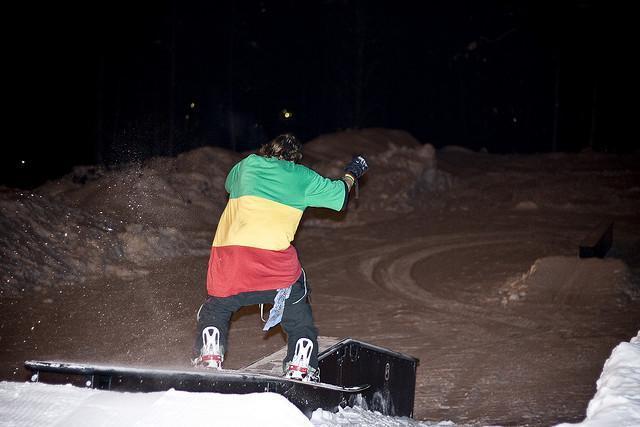How many colors are in the boy's shirt?
Give a very brief answer. 3. How many cars have a surfboard on the roof?
Give a very brief answer. 0. 